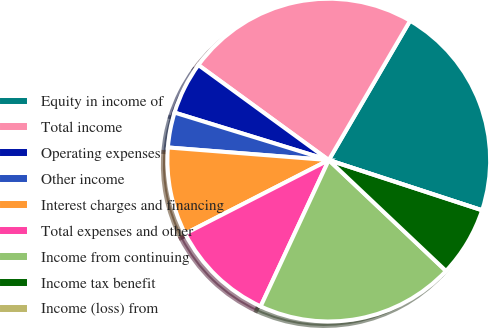<chart> <loc_0><loc_0><loc_500><loc_500><pie_chart><fcel>Equity in income of<fcel>Total income<fcel>Operating expenses<fcel>Other income<fcel>Interest charges and financing<fcel>Total expenses and other<fcel>Income from continuing<fcel>Income tax benefit<fcel>Income (loss) from<nl><fcel>21.63%<fcel>23.38%<fcel>5.27%<fcel>3.51%<fcel>8.78%<fcel>10.53%<fcel>19.88%<fcel>7.02%<fcel>0.0%<nl></chart> 